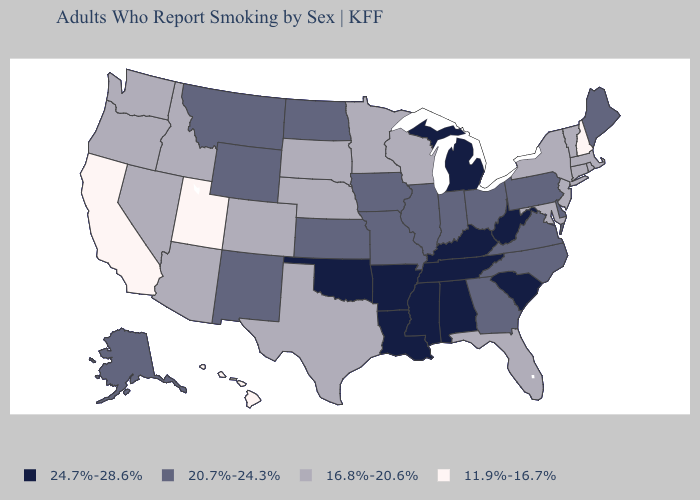Among the states that border Illinois , does Wisconsin have the lowest value?
Give a very brief answer. Yes. Does Hawaii have the lowest value in the USA?
Quick response, please. Yes. Name the states that have a value in the range 11.9%-16.7%?
Short answer required. California, Hawaii, New Hampshire, Utah. Name the states that have a value in the range 24.7%-28.6%?
Concise answer only. Alabama, Arkansas, Kentucky, Louisiana, Michigan, Mississippi, Oklahoma, South Carolina, Tennessee, West Virginia. How many symbols are there in the legend?
Write a very short answer. 4. Name the states that have a value in the range 11.9%-16.7%?
Short answer required. California, Hawaii, New Hampshire, Utah. What is the value of Mississippi?
Answer briefly. 24.7%-28.6%. Name the states that have a value in the range 20.7%-24.3%?
Answer briefly. Alaska, Delaware, Georgia, Illinois, Indiana, Iowa, Kansas, Maine, Missouri, Montana, New Mexico, North Carolina, North Dakota, Ohio, Pennsylvania, Virginia, Wyoming. Name the states that have a value in the range 11.9%-16.7%?
Concise answer only. California, Hawaii, New Hampshire, Utah. Which states have the highest value in the USA?
Keep it brief. Alabama, Arkansas, Kentucky, Louisiana, Michigan, Mississippi, Oklahoma, South Carolina, Tennessee, West Virginia. Does Pennsylvania have a lower value than Tennessee?
Keep it brief. Yes. What is the highest value in the USA?
Short answer required. 24.7%-28.6%. Name the states that have a value in the range 24.7%-28.6%?
Write a very short answer. Alabama, Arkansas, Kentucky, Louisiana, Michigan, Mississippi, Oklahoma, South Carolina, Tennessee, West Virginia. Which states have the lowest value in the West?
Answer briefly. California, Hawaii, Utah. What is the highest value in the USA?
Short answer required. 24.7%-28.6%. 